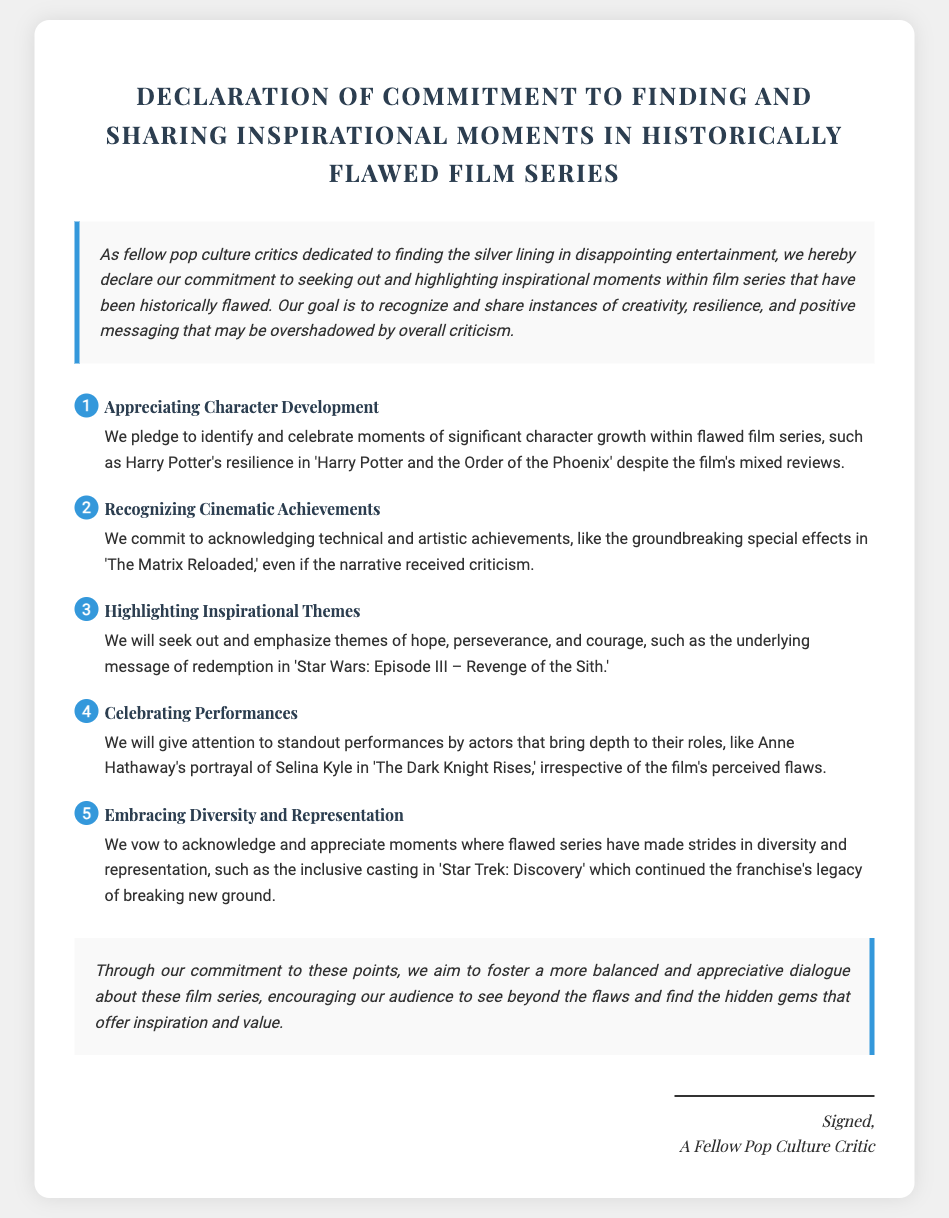what is the title of the document? The title of the document is prominently displayed as "Declaration of Commitment to Finding and Sharing Inspirational Moments in Historically Flawed Film Series."
Answer: Declaration of Commitment to Finding and Sharing Inspirational Moments in Historically Flawed Film Series who signed the document? The signature section of the document identifies the signer as "A Fellow Pop Culture Critic."
Answer: A Fellow Pop Culture Critic how many commitment points are listed? The number of commitment points can be counted from the document, which lists five specific commitments.
Answer: 5 which film series is mentioned for character development? The specific film series mentioned for character development is "Harry Potter."
Answer: Harry Potter what theme is emphasized in 'Star Wars: Episode III – Revenge of the Sith'? The emphasis on 'Star Wars: Episode III – Revenge of the Sith' is on the theme of redemption.
Answer: redemption what type of achievements does the document discuss in relation to 'The Matrix Reloaded'? The document discusses "technical and artistic achievements" in relation to 'The Matrix Reloaded.'
Answer: technical and artistic achievements what is the main goal of the declaration? The main goal of the declaration is to "recognize and share instances of creativity, resilience, and positive messaging."
Answer: recognize and share instances of creativity, resilience, and positive messaging which film's performance is highlighted as standout? The document highlights Anne Hathaway's performance in "The Dark Knight Rises" as standout.
Answer: The Dark Knight Rises 